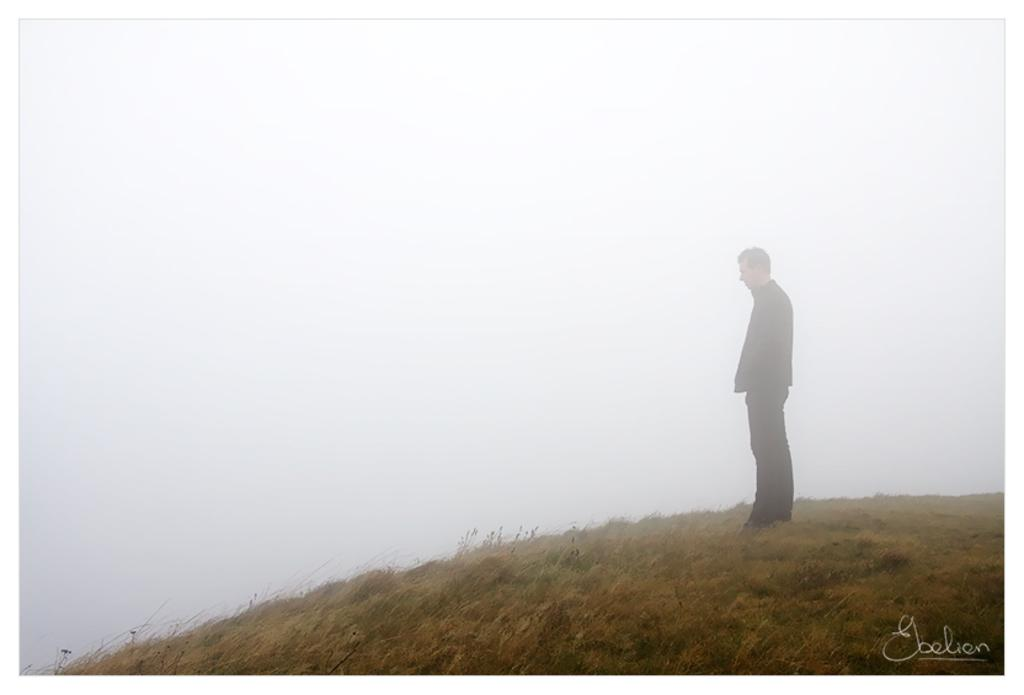What is the main subject of the image? There is a man standing in the image. What type of surface is the man standing on? There is grass on the ground in the image. How would you describe the sky in the image? The sky is cloudy in the image. What type of cream is being applied to the man's skin in the image? There is no cream or any indication of skin treatment in the image; it only shows a man standing on grass with a cloudy sky. 